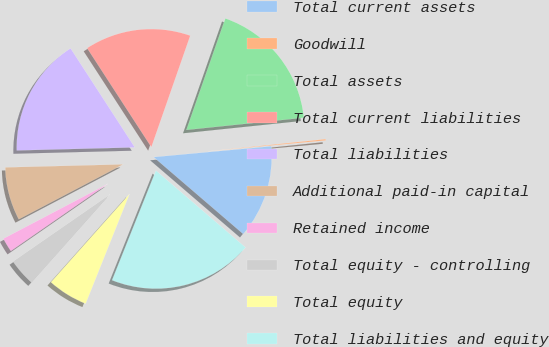Convert chart to OTSL. <chart><loc_0><loc_0><loc_500><loc_500><pie_chart><fcel>Total current assets<fcel>Goodwill<fcel>Total assets<fcel>Total current liabilities<fcel>Total liabilities<fcel>Additional paid-in capital<fcel>Retained income<fcel>Total equity - controlling<fcel>Total equity<fcel>Total liabilities and equity<nl><fcel>12.75%<fcel>0.19%<fcel>18.01%<fcel>14.5%<fcel>16.25%<fcel>7.29%<fcel>1.94%<fcel>3.78%<fcel>5.53%<fcel>19.76%<nl></chart> 